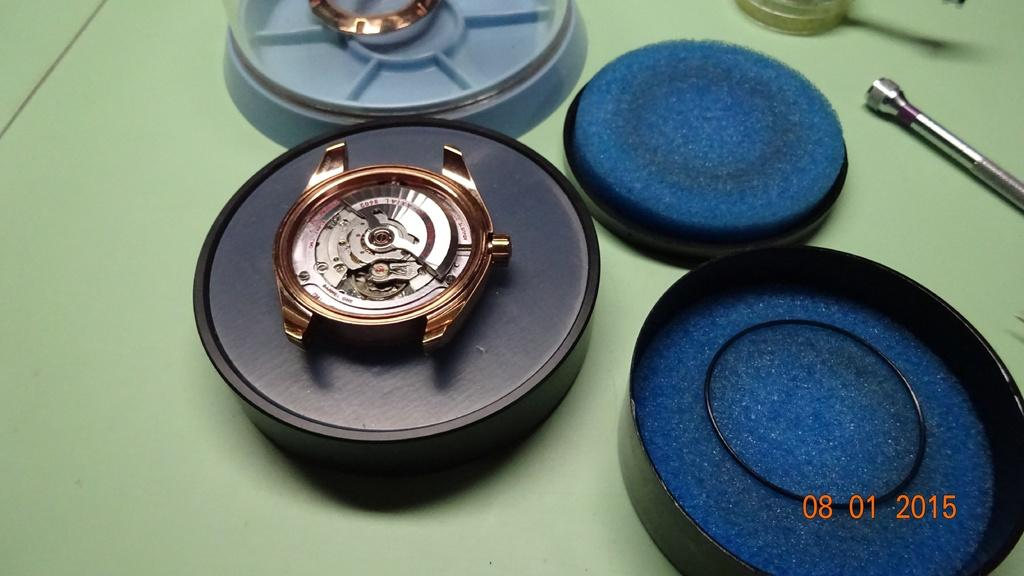What objects are present in the image? There are boxes, a watch, and a torch visible in the image. Where is the watch located in the image? The watch is in the middle of the image. What can be seen on the right side of the image? There appears to be a torch on the right side of the image. What information is provided at the right bottom of the image? There are numbers visible at the right bottom of the image. How many ants are crawling on the watch in the image? There are no ants present in the image, and therefore no ants are crawling on the watch. What type of rod is used to hold the torch in the image? There is no rod visible in the image; the torch appears to be resting on a surface. 